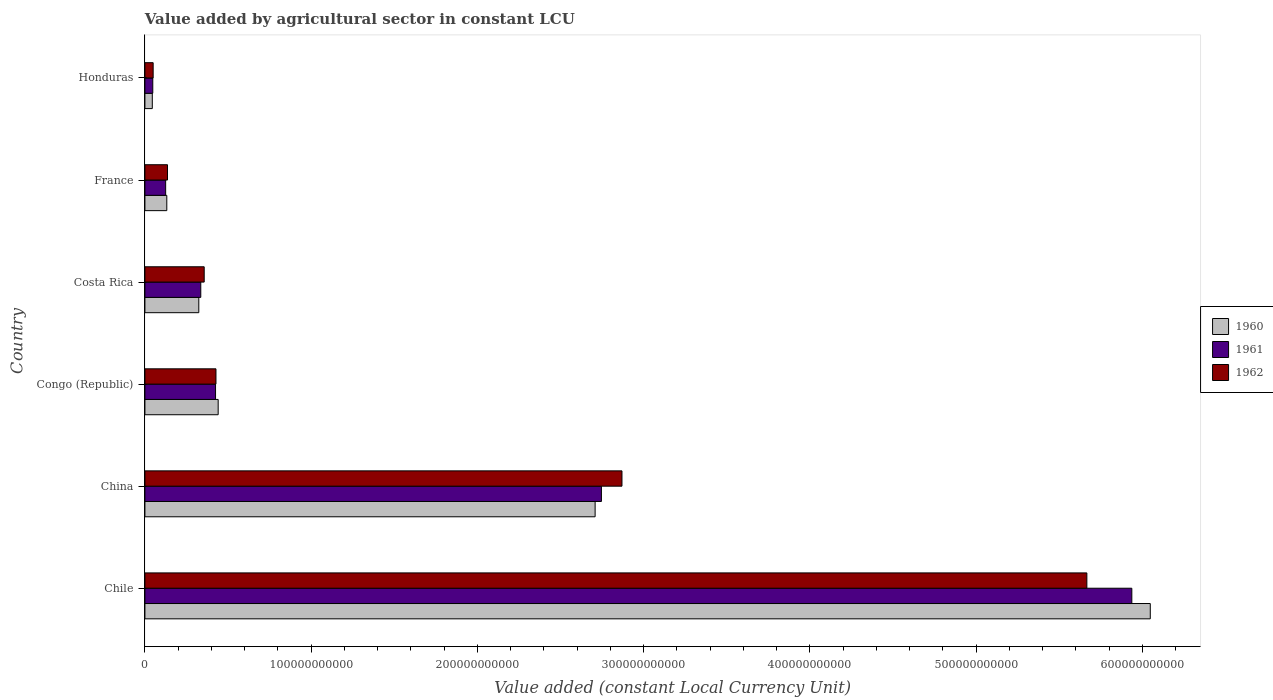How many groups of bars are there?
Your answer should be compact. 6. Are the number of bars per tick equal to the number of legend labels?
Make the answer very short. Yes. What is the label of the 1st group of bars from the top?
Ensure brevity in your answer.  Honduras. In how many cases, is the number of bars for a given country not equal to the number of legend labels?
Provide a short and direct response. 0. What is the value added by agricultural sector in 1960 in Honduras?
Give a very brief answer. 4.44e+09. Across all countries, what is the maximum value added by agricultural sector in 1960?
Provide a succinct answer. 6.05e+11. Across all countries, what is the minimum value added by agricultural sector in 1960?
Your answer should be compact. 4.44e+09. In which country was the value added by agricultural sector in 1960 minimum?
Your response must be concise. Honduras. What is the total value added by agricultural sector in 1961 in the graph?
Ensure brevity in your answer.  9.61e+11. What is the difference between the value added by agricultural sector in 1962 in Congo (Republic) and that in Costa Rica?
Make the answer very short. 7.08e+09. What is the difference between the value added by agricultural sector in 1960 in Chile and the value added by agricultural sector in 1961 in Costa Rica?
Your answer should be very brief. 5.71e+11. What is the average value added by agricultural sector in 1960 per country?
Make the answer very short. 1.62e+11. What is the difference between the value added by agricultural sector in 1961 and value added by agricultural sector in 1962 in China?
Provide a short and direct response. -1.24e+1. In how many countries, is the value added by agricultural sector in 1960 greater than 540000000000 LCU?
Provide a succinct answer. 1. What is the ratio of the value added by agricultural sector in 1960 in Chile to that in France?
Provide a short and direct response. 45.96. Is the value added by agricultural sector in 1961 in China less than that in Congo (Republic)?
Give a very brief answer. No. Is the difference between the value added by agricultural sector in 1961 in Chile and France greater than the difference between the value added by agricultural sector in 1962 in Chile and France?
Offer a terse response. Yes. What is the difference between the highest and the second highest value added by agricultural sector in 1962?
Your answer should be very brief. 2.80e+11. What is the difference between the highest and the lowest value added by agricultural sector in 1961?
Keep it short and to the point. 5.89e+11. In how many countries, is the value added by agricultural sector in 1961 greater than the average value added by agricultural sector in 1961 taken over all countries?
Keep it short and to the point. 2. What does the 1st bar from the top in Chile represents?
Your response must be concise. 1962. What does the 3rd bar from the bottom in Honduras represents?
Keep it short and to the point. 1962. What is the difference between two consecutive major ticks on the X-axis?
Give a very brief answer. 1.00e+11. Does the graph contain any zero values?
Provide a short and direct response. No. Does the graph contain grids?
Provide a succinct answer. No. Where does the legend appear in the graph?
Provide a succinct answer. Center right. How many legend labels are there?
Ensure brevity in your answer.  3. How are the legend labels stacked?
Ensure brevity in your answer.  Vertical. What is the title of the graph?
Keep it short and to the point. Value added by agricultural sector in constant LCU. Does "2000" appear as one of the legend labels in the graph?
Your answer should be compact. No. What is the label or title of the X-axis?
Offer a terse response. Value added (constant Local Currency Unit). What is the label or title of the Y-axis?
Provide a succinct answer. Country. What is the Value added (constant Local Currency Unit) in 1960 in Chile?
Your response must be concise. 6.05e+11. What is the Value added (constant Local Currency Unit) of 1961 in Chile?
Offer a very short reply. 5.94e+11. What is the Value added (constant Local Currency Unit) of 1962 in Chile?
Your response must be concise. 5.67e+11. What is the Value added (constant Local Currency Unit) of 1960 in China?
Ensure brevity in your answer.  2.71e+11. What is the Value added (constant Local Currency Unit) of 1961 in China?
Provide a short and direct response. 2.75e+11. What is the Value added (constant Local Currency Unit) in 1962 in China?
Offer a very short reply. 2.87e+11. What is the Value added (constant Local Currency Unit) in 1960 in Congo (Republic)?
Offer a very short reply. 4.41e+1. What is the Value added (constant Local Currency Unit) of 1961 in Congo (Republic)?
Your answer should be very brief. 4.25e+1. What is the Value added (constant Local Currency Unit) in 1962 in Congo (Republic)?
Your answer should be very brief. 4.27e+1. What is the Value added (constant Local Currency Unit) in 1960 in Costa Rica?
Your response must be concise. 3.24e+1. What is the Value added (constant Local Currency Unit) in 1961 in Costa Rica?
Give a very brief answer. 3.36e+1. What is the Value added (constant Local Currency Unit) of 1962 in Costa Rica?
Offer a very short reply. 3.57e+1. What is the Value added (constant Local Currency Unit) of 1960 in France?
Your answer should be compact. 1.32e+1. What is the Value added (constant Local Currency Unit) of 1961 in France?
Provide a succinct answer. 1.25e+1. What is the Value added (constant Local Currency Unit) of 1962 in France?
Make the answer very short. 1.36e+1. What is the Value added (constant Local Currency Unit) of 1960 in Honduras?
Ensure brevity in your answer.  4.44e+09. What is the Value added (constant Local Currency Unit) of 1961 in Honduras?
Offer a very short reply. 4.73e+09. What is the Value added (constant Local Currency Unit) in 1962 in Honduras?
Ensure brevity in your answer.  4.96e+09. Across all countries, what is the maximum Value added (constant Local Currency Unit) of 1960?
Provide a succinct answer. 6.05e+11. Across all countries, what is the maximum Value added (constant Local Currency Unit) of 1961?
Your answer should be very brief. 5.94e+11. Across all countries, what is the maximum Value added (constant Local Currency Unit) of 1962?
Ensure brevity in your answer.  5.67e+11. Across all countries, what is the minimum Value added (constant Local Currency Unit) in 1960?
Your answer should be very brief. 4.44e+09. Across all countries, what is the minimum Value added (constant Local Currency Unit) in 1961?
Your answer should be compact. 4.73e+09. Across all countries, what is the minimum Value added (constant Local Currency Unit) of 1962?
Make the answer very short. 4.96e+09. What is the total Value added (constant Local Currency Unit) of 1960 in the graph?
Offer a terse response. 9.70e+11. What is the total Value added (constant Local Currency Unit) in 1961 in the graph?
Your answer should be compact. 9.61e+11. What is the total Value added (constant Local Currency Unit) in 1962 in the graph?
Ensure brevity in your answer.  9.50e+11. What is the difference between the Value added (constant Local Currency Unit) in 1960 in Chile and that in China?
Your response must be concise. 3.34e+11. What is the difference between the Value added (constant Local Currency Unit) in 1961 in Chile and that in China?
Your answer should be compact. 3.19e+11. What is the difference between the Value added (constant Local Currency Unit) in 1962 in Chile and that in China?
Provide a succinct answer. 2.80e+11. What is the difference between the Value added (constant Local Currency Unit) in 1960 in Chile and that in Congo (Republic)?
Your answer should be compact. 5.61e+11. What is the difference between the Value added (constant Local Currency Unit) in 1961 in Chile and that in Congo (Republic)?
Make the answer very short. 5.51e+11. What is the difference between the Value added (constant Local Currency Unit) of 1962 in Chile and that in Congo (Republic)?
Your answer should be very brief. 5.24e+11. What is the difference between the Value added (constant Local Currency Unit) in 1960 in Chile and that in Costa Rica?
Provide a succinct answer. 5.72e+11. What is the difference between the Value added (constant Local Currency Unit) in 1961 in Chile and that in Costa Rica?
Provide a short and direct response. 5.60e+11. What is the difference between the Value added (constant Local Currency Unit) of 1962 in Chile and that in Costa Rica?
Ensure brevity in your answer.  5.31e+11. What is the difference between the Value added (constant Local Currency Unit) in 1960 in Chile and that in France?
Your answer should be very brief. 5.92e+11. What is the difference between the Value added (constant Local Currency Unit) of 1961 in Chile and that in France?
Offer a terse response. 5.81e+11. What is the difference between the Value added (constant Local Currency Unit) of 1962 in Chile and that in France?
Make the answer very short. 5.53e+11. What is the difference between the Value added (constant Local Currency Unit) in 1960 in Chile and that in Honduras?
Make the answer very short. 6.00e+11. What is the difference between the Value added (constant Local Currency Unit) of 1961 in Chile and that in Honduras?
Your answer should be very brief. 5.89e+11. What is the difference between the Value added (constant Local Currency Unit) of 1962 in Chile and that in Honduras?
Your answer should be compact. 5.62e+11. What is the difference between the Value added (constant Local Currency Unit) of 1960 in China and that in Congo (Republic)?
Your answer should be very brief. 2.27e+11. What is the difference between the Value added (constant Local Currency Unit) of 1961 in China and that in Congo (Republic)?
Ensure brevity in your answer.  2.32e+11. What is the difference between the Value added (constant Local Currency Unit) of 1962 in China and that in Congo (Republic)?
Provide a short and direct response. 2.44e+11. What is the difference between the Value added (constant Local Currency Unit) in 1960 in China and that in Costa Rica?
Provide a succinct answer. 2.38e+11. What is the difference between the Value added (constant Local Currency Unit) in 1961 in China and that in Costa Rica?
Offer a terse response. 2.41e+11. What is the difference between the Value added (constant Local Currency Unit) of 1962 in China and that in Costa Rica?
Your answer should be compact. 2.51e+11. What is the difference between the Value added (constant Local Currency Unit) in 1960 in China and that in France?
Make the answer very short. 2.58e+11. What is the difference between the Value added (constant Local Currency Unit) in 1961 in China and that in France?
Offer a very short reply. 2.62e+11. What is the difference between the Value added (constant Local Currency Unit) in 1962 in China and that in France?
Your answer should be compact. 2.73e+11. What is the difference between the Value added (constant Local Currency Unit) in 1960 in China and that in Honduras?
Make the answer very short. 2.66e+11. What is the difference between the Value added (constant Local Currency Unit) in 1961 in China and that in Honduras?
Provide a succinct answer. 2.70e+11. What is the difference between the Value added (constant Local Currency Unit) of 1962 in China and that in Honduras?
Ensure brevity in your answer.  2.82e+11. What is the difference between the Value added (constant Local Currency Unit) of 1960 in Congo (Republic) and that in Costa Rica?
Ensure brevity in your answer.  1.17e+1. What is the difference between the Value added (constant Local Currency Unit) of 1961 in Congo (Republic) and that in Costa Rica?
Make the answer very short. 8.89e+09. What is the difference between the Value added (constant Local Currency Unit) of 1962 in Congo (Republic) and that in Costa Rica?
Provide a succinct answer. 7.08e+09. What is the difference between the Value added (constant Local Currency Unit) of 1960 in Congo (Republic) and that in France?
Make the answer very short. 3.09e+1. What is the difference between the Value added (constant Local Currency Unit) in 1961 in Congo (Republic) and that in France?
Your answer should be compact. 3.00e+1. What is the difference between the Value added (constant Local Currency Unit) in 1962 in Congo (Republic) and that in France?
Provide a succinct answer. 2.92e+1. What is the difference between the Value added (constant Local Currency Unit) in 1960 in Congo (Republic) and that in Honduras?
Your answer should be compact. 3.96e+1. What is the difference between the Value added (constant Local Currency Unit) in 1961 in Congo (Republic) and that in Honduras?
Offer a terse response. 3.78e+1. What is the difference between the Value added (constant Local Currency Unit) of 1962 in Congo (Republic) and that in Honduras?
Ensure brevity in your answer.  3.78e+1. What is the difference between the Value added (constant Local Currency Unit) of 1960 in Costa Rica and that in France?
Offer a terse response. 1.92e+1. What is the difference between the Value added (constant Local Currency Unit) of 1961 in Costa Rica and that in France?
Offer a terse response. 2.11e+1. What is the difference between the Value added (constant Local Currency Unit) of 1962 in Costa Rica and that in France?
Keep it short and to the point. 2.21e+1. What is the difference between the Value added (constant Local Currency Unit) of 1960 in Costa Rica and that in Honduras?
Keep it short and to the point. 2.80e+1. What is the difference between the Value added (constant Local Currency Unit) in 1961 in Costa Rica and that in Honduras?
Offer a very short reply. 2.89e+1. What is the difference between the Value added (constant Local Currency Unit) of 1962 in Costa Rica and that in Honduras?
Give a very brief answer. 3.07e+1. What is the difference between the Value added (constant Local Currency Unit) of 1960 in France and that in Honduras?
Provide a succinct answer. 8.72e+09. What is the difference between the Value added (constant Local Currency Unit) of 1961 in France and that in Honduras?
Make the answer very short. 7.74e+09. What is the difference between the Value added (constant Local Currency Unit) of 1962 in France and that in Honduras?
Provide a short and direct response. 8.63e+09. What is the difference between the Value added (constant Local Currency Unit) in 1960 in Chile and the Value added (constant Local Currency Unit) in 1961 in China?
Your answer should be compact. 3.30e+11. What is the difference between the Value added (constant Local Currency Unit) in 1960 in Chile and the Value added (constant Local Currency Unit) in 1962 in China?
Offer a terse response. 3.18e+11. What is the difference between the Value added (constant Local Currency Unit) in 1961 in Chile and the Value added (constant Local Currency Unit) in 1962 in China?
Provide a succinct answer. 3.07e+11. What is the difference between the Value added (constant Local Currency Unit) in 1960 in Chile and the Value added (constant Local Currency Unit) in 1961 in Congo (Republic)?
Offer a very short reply. 5.62e+11. What is the difference between the Value added (constant Local Currency Unit) of 1960 in Chile and the Value added (constant Local Currency Unit) of 1962 in Congo (Republic)?
Give a very brief answer. 5.62e+11. What is the difference between the Value added (constant Local Currency Unit) of 1961 in Chile and the Value added (constant Local Currency Unit) of 1962 in Congo (Republic)?
Offer a very short reply. 5.51e+11. What is the difference between the Value added (constant Local Currency Unit) in 1960 in Chile and the Value added (constant Local Currency Unit) in 1961 in Costa Rica?
Your response must be concise. 5.71e+11. What is the difference between the Value added (constant Local Currency Unit) in 1960 in Chile and the Value added (constant Local Currency Unit) in 1962 in Costa Rica?
Provide a succinct answer. 5.69e+11. What is the difference between the Value added (constant Local Currency Unit) in 1961 in Chile and the Value added (constant Local Currency Unit) in 1962 in Costa Rica?
Keep it short and to the point. 5.58e+11. What is the difference between the Value added (constant Local Currency Unit) in 1960 in Chile and the Value added (constant Local Currency Unit) in 1961 in France?
Your response must be concise. 5.92e+11. What is the difference between the Value added (constant Local Currency Unit) of 1960 in Chile and the Value added (constant Local Currency Unit) of 1962 in France?
Offer a terse response. 5.91e+11. What is the difference between the Value added (constant Local Currency Unit) of 1961 in Chile and the Value added (constant Local Currency Unit) of 1962 in France?
Make the answer very short. 5.80e+11. What is the difference between the Value added (constant Local Currency Unit) of 1960 in Chile and the Value added (constant Local Currency Unit) of 1961 in Honduras?
Your response must be concise. 6.00e+11. What is the difference between the Value added (constant Local Currency Unit) of 1960 in Chile and the Value added (constant Local Currency Unit) of 1962 in Honduras?
Keep it short and to the point. 6.00e+11. What is the difference between the Value added (constant Local Currency Unit) in 1961 in Chile and the Value added (constant Local Currency Unit) in 1962 in Honduras?
Keep it short and to the point. 5.89e+11. What is the difference between the Value added (constant Local Currency Unit) in 1960 in China and the Value added (constant Local Currency Unit) in 1961 in Congo (Republic)?
Offer a very short reply. 2.28e+11. What is the difference between the Value added (constant Local Currency Unit) of 1960 in China and the Value added (constant Local Currency Unit) of 1962 in Congo (Republic)?
Provide a short and direct response. 2.28e+11. What is the difference between the Value added (constant Local Currency Unit) of 1961 in China and the Value added (constant Local Currency Unit) of 1962 in Congo (Republic)?
Provide a short and direct response. 2.32e+11. What is the difference between the Value added (constant Local Currency Unit) of 1960 in China and the Value added (constant Local Currency Unit) of 1961 in Costa Rica?
Your answer should be very brief. 2.37e+11. What is the difference between the Value added (constant Local Currency Unit) of 1960 in China and the Value added (constant Local Currency Unit) of 1962 in Costa Rica?
Your response must be concise. 2.35e+11. What is the difference between the Value added (constant Local Currency Unit) in 1961 in China and the Value added (constant Local Currency Unit) in 1962 in Costa Rica?
Give a very brief answer. 2.39e+11. What is the difference between the Value added (constant Local Currency Unit) of 1960 in China and the Value added (constant Local Currency Unit) of 1961 in France?
Your answer should be very brief. 2.58e+11. What is the difference between the Value added (constant Local Currency Unit) of 1960 in China and the Value added (constant Local Currency Unit) of 1962 in France?
Your answer should be compact. 2.57e+11. What is the difference between the Value added (constant Local Currency Unit) of 1961 in China and the Value added (constant Local Currency Unit) of 1962 in France?
Your answer should be compact. 2.61e+11. What is the difference between the Value added (constant Local Currency Unit) of 1960 in China and the Value added (constant Local Currency Unit) of 1961 in Honduras?
Offer a very short reply. 2.66e+11. What is the difference between the Value added (constant Local Currency Unit) in 1960 in China and the Value added (constant Local Currency Unit) in 1962 in Honduras?
Provide a short and direct response. 2.66e+11. What is the difference between the Value added (constant Local Currency Unit) of 1961 in China and the Value added (constant Local Currency Unit) of 1962 in Honduras?
Offer a terse response. 2.70e+11. What is the difference between the Value added (constant Local Currency Unit) in 1960 in Congo (Republic) and the Value added (constant Local Currency Unit) in 1961 in Costa Rica?
Make the answer very short. 1.05e+1. What is the difference between the Value added (constant Local Currency Unit) in 1960 in Congo (Republic) and the Value added (constant Local Currency Unit) in 1962 in Costa Rica?
Your answer should be compact. 8.40e+09. What is the difference between the Value added (constant Local Currency Unit) of 1961 in Congo (Republic) and the Value added (constant Local Currency Unit) of 1962 in Costa Rica?
Provide a short and direct response. 6.83e+09. What is the difference between the Value added (constant Local Currency Unit) in 1960 in Congo (Republic) and the Value added (constant Local Currency Unit) in 1961 in France?
Give a very brief answer. 3.16e+1. What is the difference between the Value added (constant Local Currency Unit) of 1960 in Congo (Republic) and the Value added (constant Local Currency Unit) of 1962 in France?
Provide a short and direct response. 3.05e+1. What is the difference between the Value added (constant Local Currency Unit) in 1961 in Congo (Republic) and the Value added (constant Local Currency Unit) in 1962 in France?
Your answer should be very brief. 2.89e+1. What is the difference between the Value added (constant Local Currency Unit) in 1960 in Congo (Republic) and the Value added (constant Local Currency Unit) in 1961 in Honduras?
Your answer should be very brief. 3.93e+1. What is the difference between the Value added (constant Local Currency Unit) of 1960 in Congo (Republic) and the Value added (constant Local Currency Unit) of 1962 in Honduras?
Keep it short and to the point. 3.91e+1. What is the difference between the Value added (constant Local Currency Unit) of 1961 in Congo (Republic) and the Value added (constant Local Currency Unit) of 1962 in Honduras?
Your response must be concise. 3.75e+1. What is the difference between the Value added (constant Local Currency Unit) in 1960 in Costa Rica and the Value added (constant Local Currency Unit) in 1961 in France?
Make the answer very short. 1.99e+1. What is the difference between the Value added (constant Local Currency Unit) of 1960 in Costa Rica and the Value added (constant Local Currency Unit) of 1962 in France?
Provide a succinct answer. 1.88e+1. What is the difference between the Value added (constant Local Currency Unit) of 1961 in Costa Rica and the Value added (constant Local Currency Unit) of 1962 in France?
Ensure brevity in your answer.  2.00e+1. What is the difference between the Value added (constant Local Currency Unit) of 1960 in Costa Rica and the Value added (constant Local Currency Unit) of 1961 in Honduras?
Offer a terse response. 2.77e+1. What is the difference between the Value added (constant Local Currency Unit) of 1960 in Costa Rica and the Value added (constant Local Currency Unit) of 1962 in Honduras?
Provide a succinct answer. 2.74e+1. What is the difference between the Value added (constant Local Currency Unit) in 1961 in Costa Rica and the Value added (constant Local Currency Unit) in 1962 in Honduras?
Your answer should be very brief. 2.86e+1. What is the difference between the Value added (constant Local Currency Unit) in 1960 in France and the Value added (constant Local Currency Unit) in 1961 in Honduras?
Give a very brief answer. 8.43e+09. What is the difference between the Value added (constant Local Currency Unit) of 1960 in France and the Value added (constant Local Currency Unit) of 1962 in Honduras?
Provide a short and direct response. 8.20e+09. What is the difference between the Value added (constant Local Currency Unit) in 1961 in France and the Value added (constant Local Currency Unit) in 1962 in Honduras?
Your answer should be compact. 7.52e+09. What is the average Value added (constant Local Currency Unit) of 1960 per country?
Offer a very short reply. 1.62e+11. What is the average Value added (constant Local Currency Unit) in 1961 per country?
Provide a short and direct response. 1.60e+11. What is the average Value added (constant Local Currency Unit) in 1962 per country?
Ensure brevity in your answer.  1.58e+11. What is the difference between the Value added (constant Local Currency Unit) of 1960 and Value added (constant Local Currency Unit) of 1961 in Chile?
Provide a succinct answer. 1.11e+1. What is the difference between the Value added (constant Local Currency Unit) of 1960 and Value added (constant Local Currency Unit) of 1962 in Chile?
Keep it short and to the point. 3.82e+1. What is the difference between the Value added (constant Local Currency Unit) of 1961 and Value added (constant Local Currency Unit) of 1962 in Chile?
Your answer should be very brief. 2.70e+1. What is the difference between the Value added (constant Local Currency Unit) in 1960 and Value added (constant Local Currency Unit) in 1961 in China?
Your answer should be compact. -3.79e+09. What is the difference between the Value added (constant Local Currency Unit) of 1960 and Value added (constant Local Currency Unit) of 1962 in China?
Make the answer very short. -1.61e+1. What is the difference between the Value added (constant Local Currency Unit) in 1961 and Value added (constant Local Currency Unit) in 1962 in China?
Make the answer very short. -1.24e+1. What is the difference between the Value added (constant Local Currency Unit) of 1960 and Value added (constant Local Currency Unit) of 1961 in Congo (Republic)?
Your answer should be very brief. 1.57e+09. What is the difference between the Value added (constant Local Currency Unit) in 1960 and Value added (constant Local Currency Unit) in 1962 in Congo (Republic)?
Provide a succinct answer. 1.32e+09. What is the difference between the Value added (constant Local Currency Unit) of 1961 and Value added (constant Local Currency Unit) of 1962 in Congo (Republic)?
Offer a terse response. -2.56e+08. What is the difference between the Value added (constant Local Currency Unit) of 1960 and Value added (constant Local Currency Unit) of 1961 in Costa Rica?
Offer a terse response. -1.19e+09. What is the difference between the Value added (constant Local Currency Unit) in 1960 and Value added (constant Local Currency Unit) in 1962 in Costa Rica?
Provide a succinct answer. -3.25e+09. What is the difference between the Value added (constant Local Currency Unit) of 1961 and Value added (constant Local Currency Unit) of 1962 in Costa Rica?
Keep it short and to the point. -2.06e+09. What is the difference between the Value added (constant Local Currency Unit) of 1960 and Value added (constant Local Currency Unit) of 1961 in France?
Your answer should be very brief. 6.84e+08. What is the difference between the Value added (constant Local Currency Unit) in 1960 and Value added (constant Local Currency Unit) in 1962 in France?
Offer a very short reply. -4.23e+08. What is the difference between the Value added (constant Local Currency Unit) in 1961 and Value added (constant Local Currency Unit) in 1962 in France?
Offer a very short reply. -1.11e+09. What is the difference between the Value added (constant Local Currency Unit) of 1960 and Value added (constant Local Currency Unit) of 1961 in Honduras?
Keep it short and to the point. -2.90e+08. What is the difference between the Value added (constant Local Currency Unit) in 1960 and Value added (constant Local Currency Unit) in 1962 in Honduras?
Ensure brevity in your answer.  -5.15e+08. What is the difference between the Value added (constant Local Currency Unit) in 1961 and Value added (constant Local Currency Unit) in 1962 in Honduras?
Offer a terse response. -2.25e+08. What is the ratio of the Value added (constant Local Currency Unit) of 1960 in Chile to that in China?
Offer a terse response. 2.23. What is the ratio of the Value added (constant Local Currency Unit) of 1961 in Chile to that in China?
Give a very brief answer. 2.16. What is the ratio of the Value added (constant Local Currency Unit) in 1962 in Chile to that in China?
Your answer should be very brief. 1.97. What is the ratio of the Value added (constant Local Currency Unit) of 1960 in Chile to that in Congo (Republic)?
Make the answer very short. 13.73. What is the ratio of the Value added (constant Local Currency Unit) of 1961 in Chile to that in Congo (Republic)?
Make the answer very short. 13.97. What is the ratio of the Value added (constant Local Currency Unit) in 1962 in Chile to that in Congo (Republic)?
Make the answer very short. 13.26. What is the ratio of the Value added (constant Local Currency Unit) in 1960 in Chile to that in Costa Rica?
Your answer should be very brief. 18.66. What is the ratio of the Value added (constant Local Currency Unit) of 1961 in Chile to that in Costa Rica?
Your answer should be very brief. 17.67. What is the ratio of the Value added (constant Local Currency Unit) in 1962 in Chile to that in Costa Rica?
Provide a short and direct response. 15.89. What is the ratio of the Value added (constant Local Currency Unit) of 1960 in Chile to that in France?
Offer a terse response. 45.96. What is the ratio of the Value added (constant Local Currency Unit) of 1961 in Chile to that in France?
Keep it short and to the point. 47.59. What is the ratio of the Value added (constant Local Currency Unit) of 1962 in Chile to that in France?
Provide a short and direct response. 41.72. What is the ratio of the Value added (constant Local Currency Unit) of 1960 in Chile to that in Honduras?
Provide a short and direct response. 136.17. What is the ratio of the Value added (constant Local Currency Unit) in 1961 in Chile to that in Honduras?
Give a very brief answer. 125.48. What is the ratio of the Value added (constant Local Currency Unit) in 1962 in Chile to that in Honduras?
Provide a succinct answer. 114.33. What is the ratio of the Value added (constant Local Currency Unit) in 1960 in China to that in Congo (Republic)?
Your response must be concise. 6.15. What is the ratio of the Value added (constant Local Currency Unit) in 1961 in China to that in Congo (Republic)?
Ensure brevity in your answer.  6.46. What is the ratio of the Value added (constant Local Currency Unit) of 1962 in China to that in Congo (Republic)?
Provide a short and direct response. 6.71. What is the ratio of the Value added (constant Local Currency Unit) in 1960 in China to that in Costa Rica?
Provide a succinct answer. 8.36. What is the ratio of the Value added (constant Local Currency Unit) in 1961 in China to that in Costa Rica?
Ensure brevity in your answer.  8.17. What is the ratio of the Value added (constant Local Currency Unit) in 1962 in China to that in Costa Rica?
Provide a short and direct response. 8.05. What is the ratio of the Value added (constant Local Currency Unit) in 1960 in China to that in France?
Provide a succinct answer. 20.58. What is the ratio of the Value added (constant Local Currency Unit) in 1961 in China to that in France?
Provide a short and direct response. 22.01. What is the ratio of the Value added (constant Local Currency Unit) in 1962 in China to that in France?
Ensure brevity in your answer.  21.13. What is the ratio of the Value added (constant Local Currency Unit) of 1960 in China to that in Honduras?
Keep it short and to the point. 60.98. What is the ratio of the Value added (constant Local Currency Unit) in 1961 in China to that in Honduras?
Ensure brevity in your answer.  58.04. What is the ratio of the Value added (constant Local Currency Unit) in 1962 in China to that in Honduras?
Provide a short and direct response. 57.9. What is the ratio of the Value added (constant Local Currency Unit) of 1960 in Congo (Republic) to that in Costa Rica?
Your answer should be very brief. 1.36. What is the ratio of the Value added (constant Local Currency Unit) in 1961 in Congo (Republic) to that in Costa Rica?
Your answer should be compact. 1.26. What is the ratio of the Value added (constant Local Currency Unit) in 1962 in Congo (Republic) to that in Costa Rica?
Your answer should be compact. 1.2. What is the ratio of the Value added (constant Local Currency Unit) in 1960 in Congo (Republic) to that in France?
Provide a short and direct response. 3.35. What is the ratio of the Value added (constant Local Currency Unit) in 1961 in Congo (Republic) to that in France?
Make the answer very short. 3.41. What is the ratio of the Value added (constant Local Currency Unit) in 1962 in Congo (Republic) to that in France?
Your answer should be very brief. 3.15. What is the ratio of the Value added (constant Local Currency Unit) of 1960 in Congo (Republic) to that in Honduras?
Your response must be concise. 9.92. What is the ratio of the Value added (constant Local Currency Unit) of 1961 in Congo (Republic) to that in Honduras?
Offer a terse response. 8.98. What is the ratio of the Value added (constant Local Currency Unit) in 1962 in Congo (Republic) to that in Honduras?
Make the answer very short. 8.62. What is the ratio of the Value added (constant Local Currency Unit) of 1960 in Costa Rica to that in France?
Offer a terse response. 2.46. What is the ratio of the Value added (constant Local Currency Unit) in 1961 in Costa Rica to that in France?
Keep it short and to the point. 2.69. What is the ratio of the Value added (constant Local Currency Unit) in 1962 in Costa Rica to that in France?
Keep it short and to the point. 2.63. What is the ratio of the Value added (constant Local Currency Unit) of 1960 in Costa Rica to that in Honduras?
Make the answer very short. 7.3. What is the ratio of the Value added (constant Local Currency Unit) of 1961 in Costa Rica to that in Honduras?
Your response must be concise. 7.1. What is the ratio of the Value added (constant Local Currency Unit) in 1962 in Costa Rica to that in Honduras?
Your answer should be very brief. 7.2. What is the ratio of the Value added (constant Local Currency Unit) in 1960 in France to that in Honduras?
Offer a very short reply. 2.96. What is the ratio of the Value added (constant Local Currency Unit) of 1961 in France to that in Honduras?
Give a very brief answer. 2.64. What is the ratio of the Value added (constant Local Currency Unit) of 1962 in France to that in Honduras?
Your answer should be very brief. 2.74. What is the difference between the highest and the second highest Value added (constant Local Currency Unit) in 1960?
Keep it short and to the point. 3.34e+11. What is the difference between the highest and the second highest Value added (constant Local Currency Unit) in 1961?
Offer a very short reply. 3.19e+11. What is the difference between the highest and the second highest Value added (constant Local Currency Unit) of 1962?
Keep it short and to the point. 2.80e+11. What is the difference between the highest and the lowest Value added (constant Local Currency Unit) in 1960?
Your answer should be compact. 6.00e+11. What is the difference between the highest and the lowest Value added (constant Local Currency Unit) of 1961?
Provide a succinct answer. 5.89e+11. What is the difference between the highest and the lowest Value added (constant Local Currency Unit) in 1962?
Your answer should be compact. 5.62e+11. 